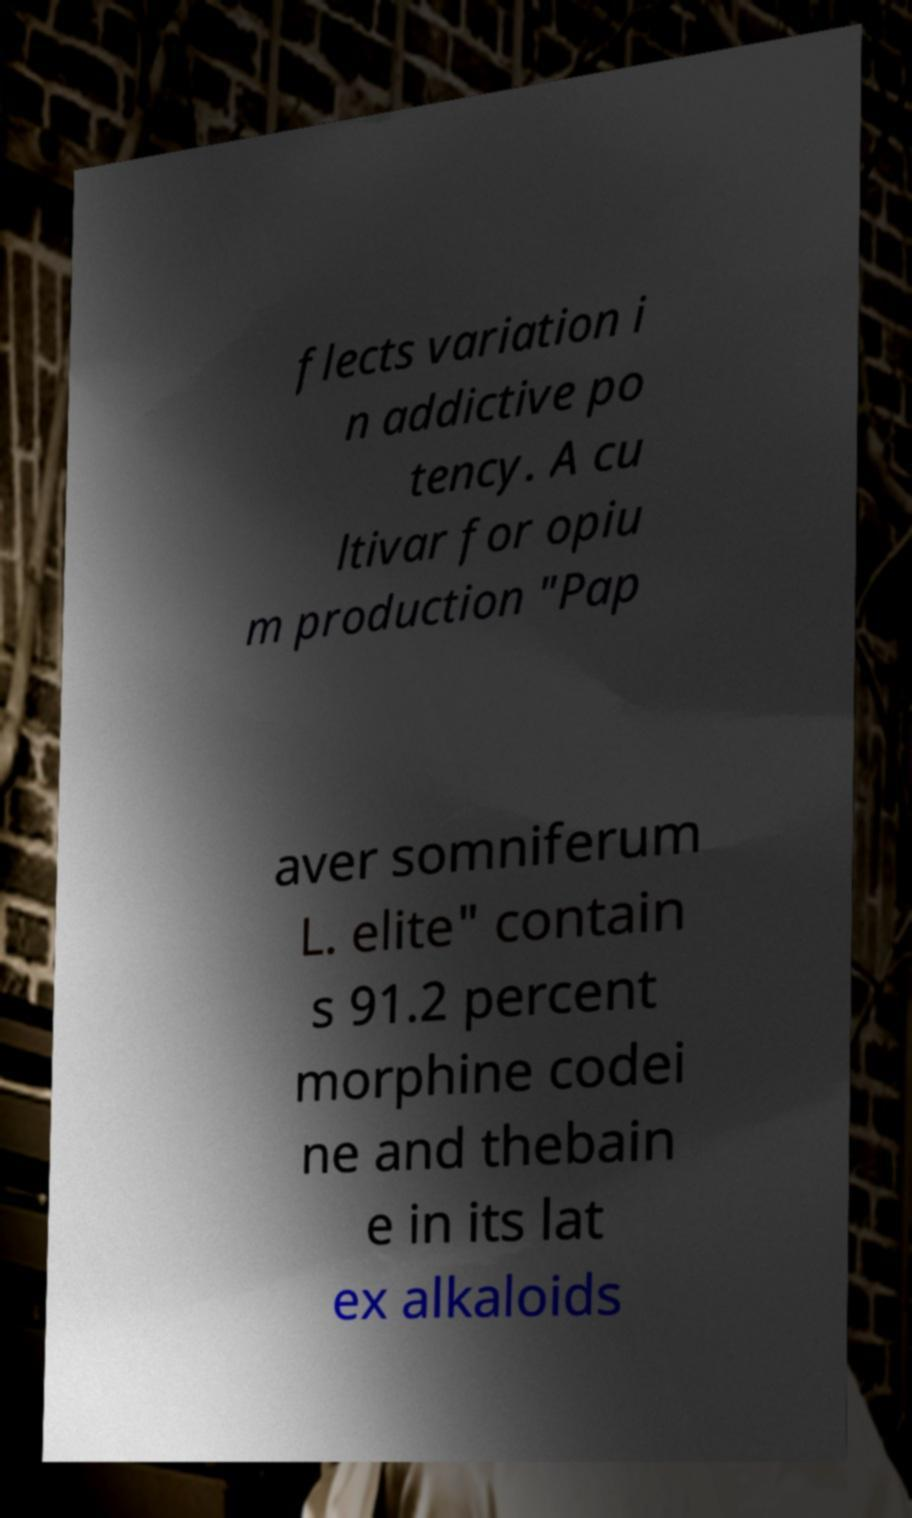Can you accurately transcribe the text from the provided image for me? flects variation i n addictive po tency. A cu ltivar for opiu m production "Pap aver somniferum L. elite" contain s 91.2 percent morphine codei ne and thebain e in its lat ex alkaloids 